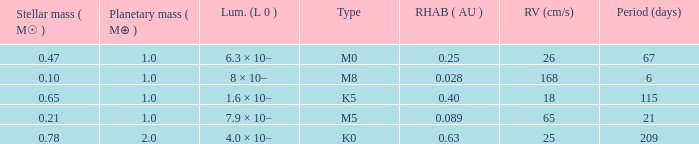What is the total stellar mass of the type m0? 0.47. 